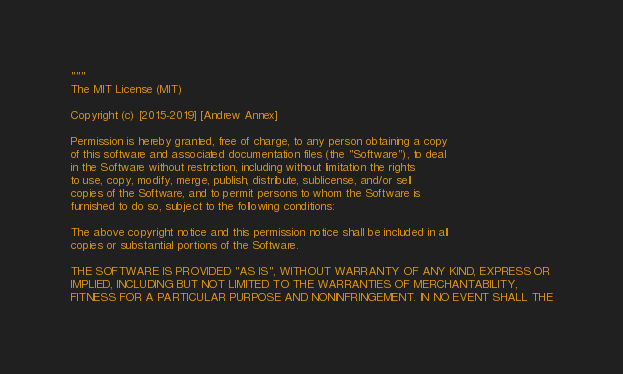Convert code to text. <code><loc_0><loc_0><loc_500><loc_500><_Python_>"""
The MIT License (MIT)

Copyright (c) [2015-2019] [Andrew Annex]

Permission is hereby granted, free of charge, to any person obtaining a copy
of this software and associated documentation files (the "Software"), to deal
in the Software without restriction, including without limitation the rights
to use, copy, modify, merge, publish, distribute, sublicense, and/or sell
copies of the Software, and to permit persons to whom the Software is
furnished to do so, subject to the following conditions:

The above copyright notice and this permission notice shall be included in all
copies or substantial portions of the Software.

THE SOFTWARE IS PROVIDED "AS IS", WITHOUT WARRANTY OF ANY KIND, EXPRESS OR
IMPLIED, INCLUDING BUT NOT LIMITED TO THE WARRANTIES OF MERCHANTABILITY,
FITNESS FOR A PARTICULAR PURPOSE AND NONINFRINGEMENT. IN NO EVENT SHALL THE</code> 